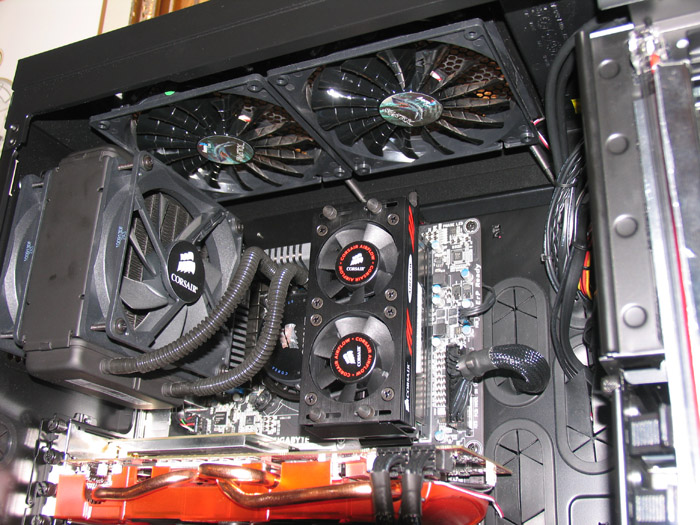Based on the visible setup, what kind of cooling system is being used, and how effective might it be under heavy load? The setup shown includes an all-in-one (AIO) liquid cooler from Corsair and additional case fans mounted at the top. AIO coolers are effective at managing the CPU temperatures, especially under heavy loads, by efficiently dissipating heat through the radiator and fan system. Together with the case fans, this setup should provide robust cooling, maintaining component temperatures within optimal ranges even during extended high-performance tasks. 